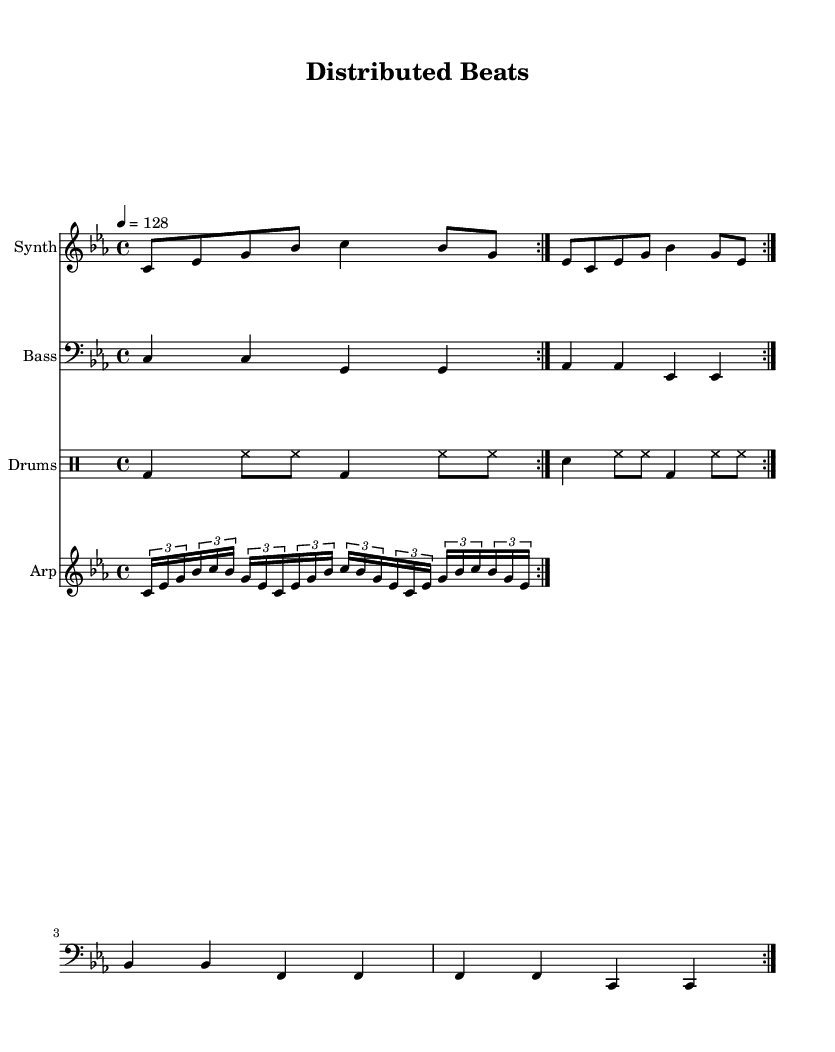What is the key signature of this music? The key signature indicates the presence of three flats, which corresponds to C minor.
Answer: C minor What is the time signature? The time signature is represented as 4/4, indicating four beats per measure.
Answer: 4/4 What is the tempo marking? The tempo marking shows that the piece should be played at a speed of 128 beats per minute.
Answer: 128 How many volte does the melody repeat? The repeat markings in the sheet music show that the melody section repeats two times.
Answer: 2 What type of rhythm is used in the drum pattern? The drum pattern combines quarter notes and eighth notes, emphasizing a steady beat typical in dance music.
Answer: Steady beat What is the structure of the arpeggiator part? The arpeggiator part utilizes tuplets, specifically grouping into threes, creating an algorithmic feel that complements the dance genre.
Answer: Tuplets What instruments are featured in this piece? The piece prominently features synthesizer, bass, drums, and arpeggiator parts, typical of electronic dance music.
Answer: Synthesizer, bass, drums, arpeggiator 